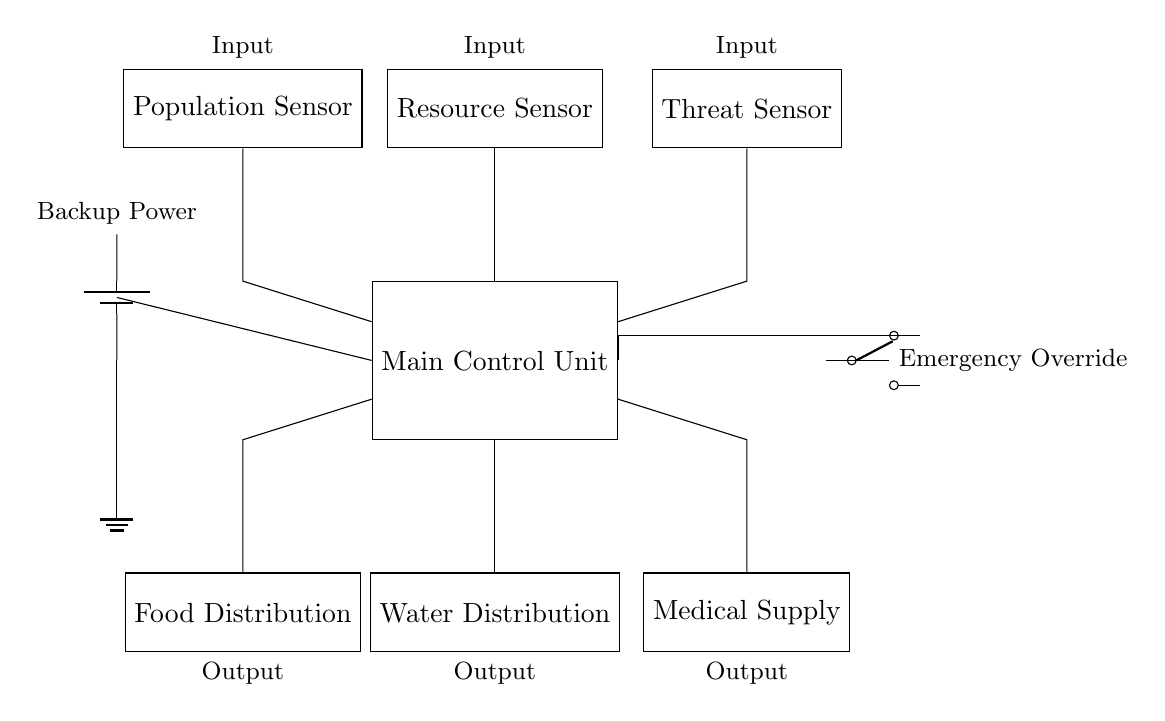What is the main control unit in the circuit? The main control unit is labeled as "Main Control Unit," which is responsible for processing inputs from various sensors and directing the distribution units.
Answer: Main Control Unit How many sensors are present in this circuit? There are three sensors shown connecting to the main control unit: Population Sensor, Resource Sensor, and Threat Sensor.
Answer: Three What kind of override mechanism is included in the circuit? The circuit includes an emergency override switch that can control the main control unit directly, ensuring functionality even during critical situations.
Answer: Emergency Override Which distribution unit is responsible for distributing food? The distribution unit labeled "Food Distribution" is identified as the one responsible for food supplies based on its designation in the circuit diagram.
Answer: Food Distribution What is the function of the power supply in this circuit? The power supply, represented by a battery, provides backup power to the main control unit, ensuring operation in case of other power failures.
Answer: Backup Power What type of sensors connect directly to the main control unit? The sensors that connect directly to the main control unit are population, resource, and threat sensors, which are critical for assessing the environment for resource distribution decisions.
Answer: Population, Resource, Threat What outputs does the main control unit control? The main control unit controls the outputs for food distribution, water distribution, and medical supply, as indicated in the diagram.
Answer: Food, Water, Medical Supply 